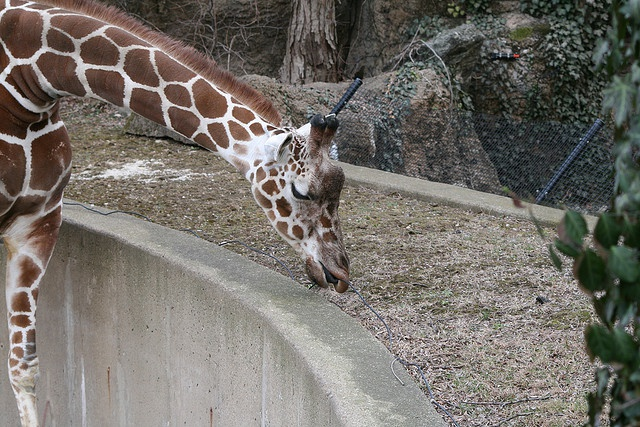Describe the objects in this image and their specific colors. I can see a giraffe in brown, maroon, gray, darkgray, and lightgray tones in this image. 